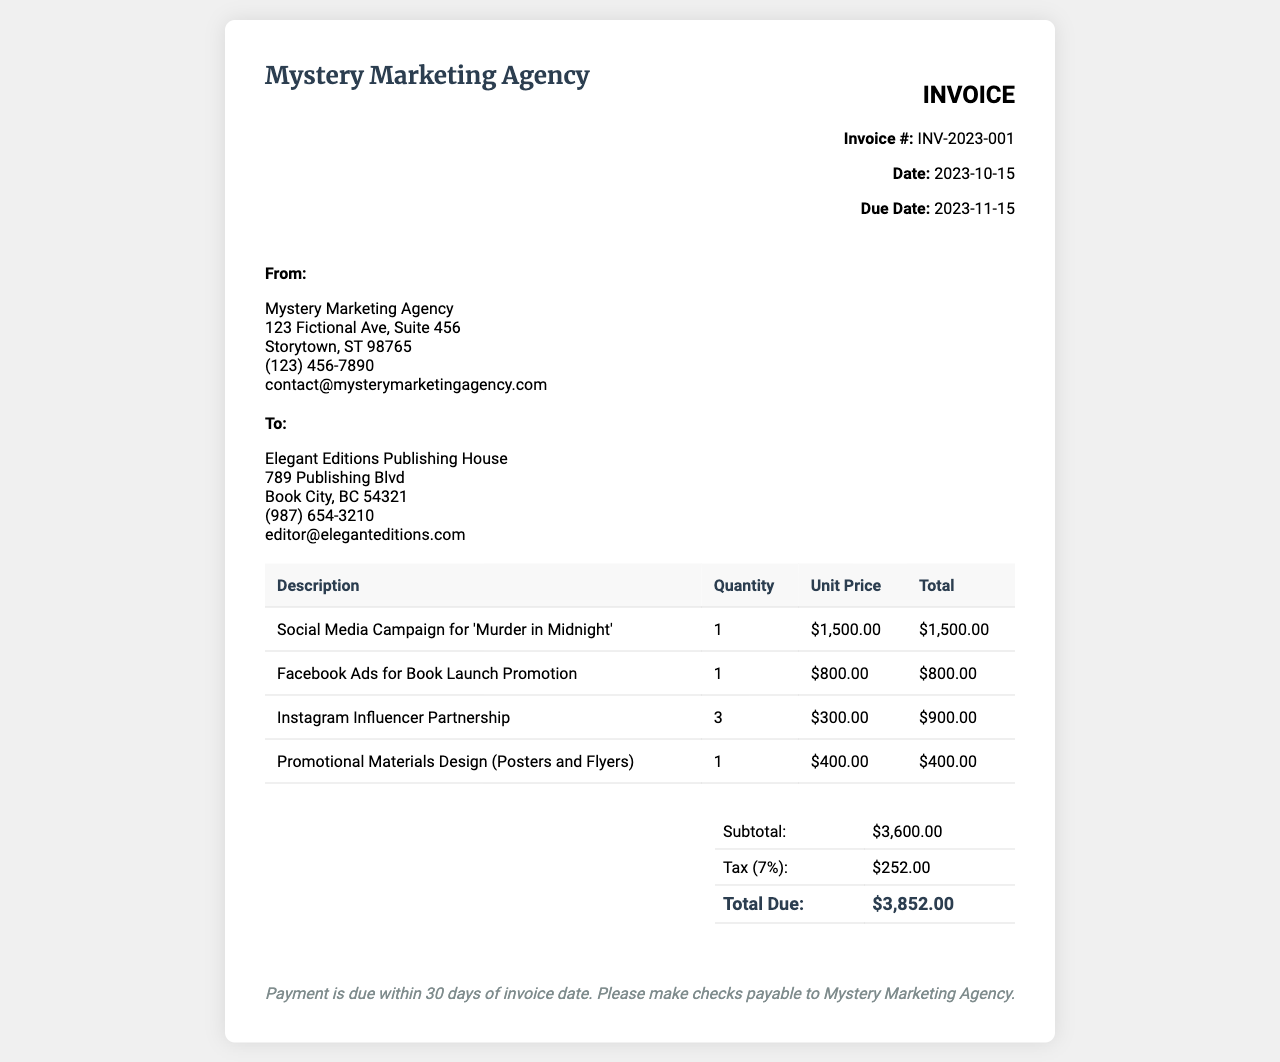What is the invoice number? The invoice number is listed under "Invoice #:" in the document.
Answer: INV-2023-001 What is the date of the invoice? The date is present next to "Date:" in the document.
Answer: 2023-10-15 What is the total due amount? The total due amount is found in the summary section of the invoice.
Answer: $3,852.00 How many Instagram influencer partnerships are included? The quantity for Instagram influencer partnerships is in the table under "Quantity".
Answer: 3 What is the subtotal amount before tax? The subtotal amount is detailed in the summary table of the invoice.
Answer: $3,600.00 What is the tax percentage applied? The tax percentage is indicated in the summary, labeled as "Tax (7%)".
Answer: 7% What is the due date for payment? The due date is specified under "Due Date:" in the document.
Answer: 2023-11-15 Who is the recipient of the invoice? The recipient is indicated under the "To:" section of the invoice.
Answer: Elegant Editions Publishing House What service was billed the highest amount? The service with the highest unit price can be identified in the table of services.
Answer: Social Media Campaign for 'Murder in Midnight' 